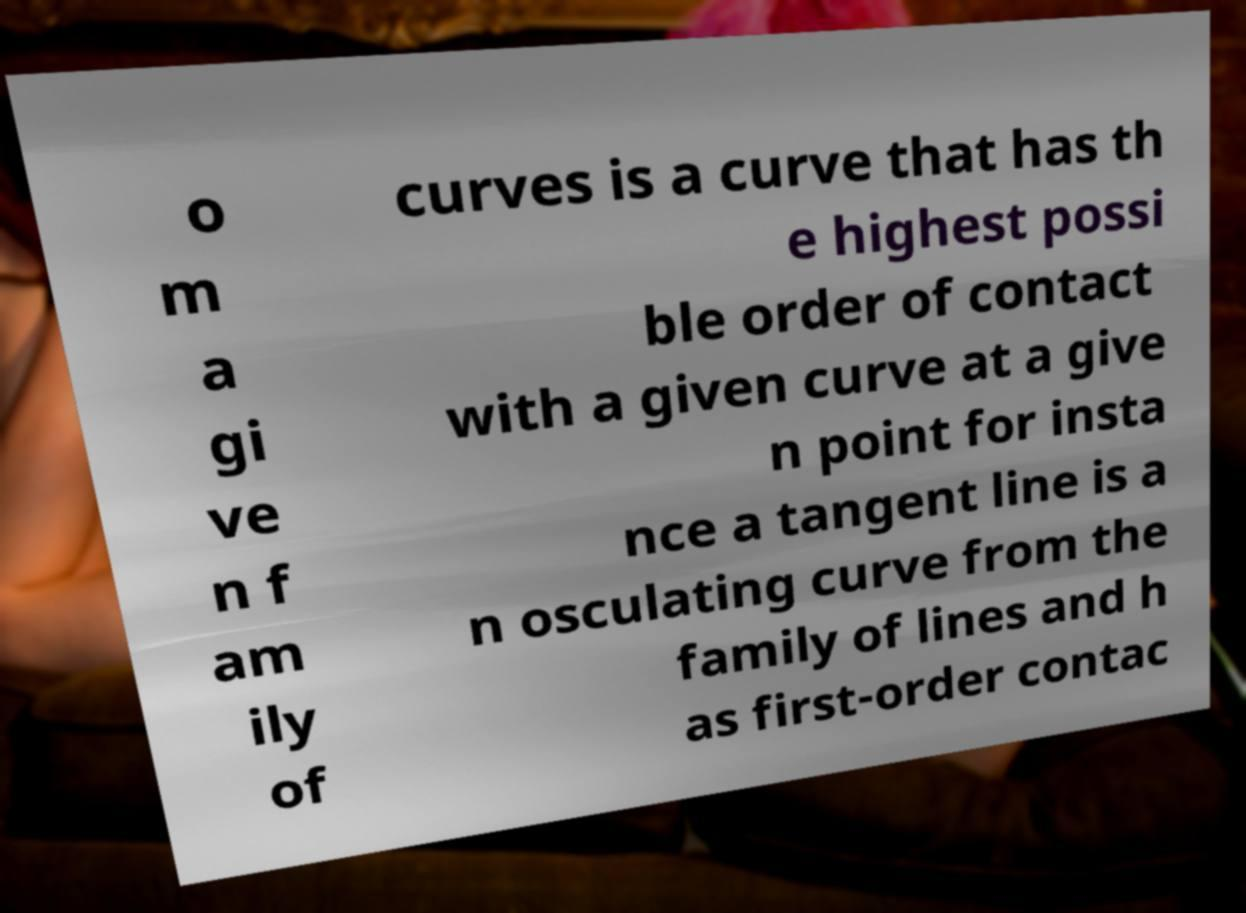For documentation purposes, I need the text within this image transcribed. Could you provide that? o m a gi ve n f am ily of curves is a curve that has th e highest possi ble order of contact with a given curve at a give n point for insta nce a tangent line is a n osculating curve from the family of lines and h as first-order contac 